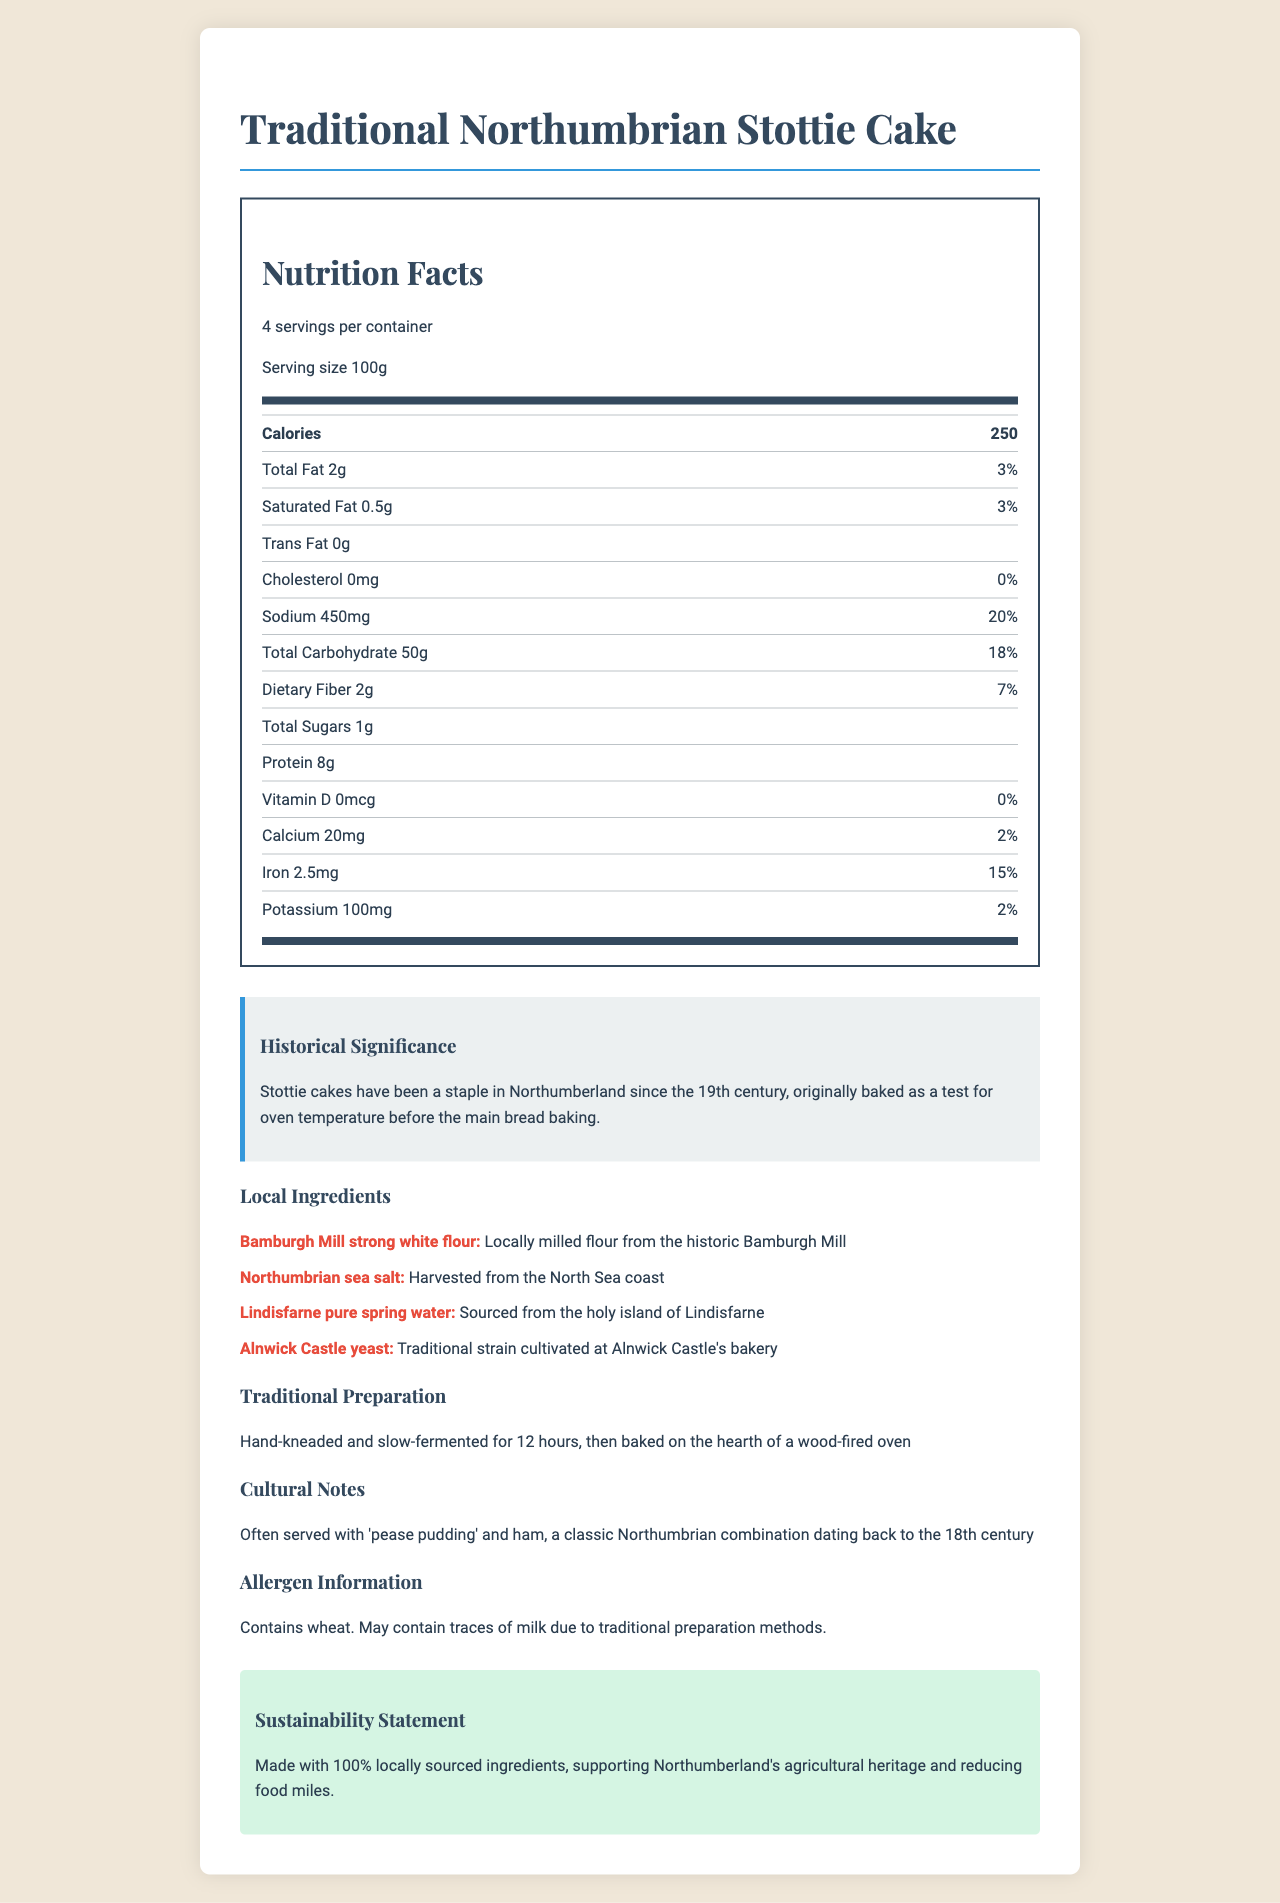what is the serving size for the Traditional Northumbrian Stottie Cake? The document states that the serving size for the Traditional Northumbrian Stottie Cake is 100g.
Answer: 100g how many calories are there per serving? The document specifies that there are 250 calories per serving.
Answer: 250 calories what is the daily value percentage for sodium? The document indicates that the daily value percentage for sodium is 20%.
Answer: 20% how much protein does the Traditional Northumbrian Stottie Cake contain per serving? According to the document, each serving contains 8g of protein.
Answer: 8g what are the main local ingredients used in the Traditional Northumbrian Stottie Cake? The document lists these ingredients as locally sourced: Bamburgh Mill strong white flour, Northumbrian sea salt, Lindisfarne pure spring water, and Alnwick Castle yeast.
Answer: Bamburgh Mill strong white flour, Northumbrian sea salt, Lindisfarne pure spring water, Alnwick Castle yeast how long is the Traditional Northumbrian Stottie Cake slow-fermented for during preparation? The document notes that the cake is slow-fermented for 12 hours during preparation.
Answer: 12 hours where is the Lindisfarne pure spring water sourced from? The document mentions that the Lindisfarne pure spring water is sourced from the holy island of Lindisfarne.
Answer: The holy island of Lindisfarne when did Stottie cakes become a staple in Northumberland? The document states that Stottie cakes have been a staple in Northumberland since the 19th century.
Answer: 19th century which local ingredient is harvested from the North Sea coast? According to the document, Northumbrian sea salt is harvested from the North Sea coast.
Answer: Northumbrian sea salt which cultural combination is the Traditional Northumbrian Stottie Cake often served with? A. Cheese and Tomato B. Pease Pudding and Ham C. Butter and Jam The document indicates that Stottie cake is often served with pease pudding and ham.
Answer: B. Pease Pudding and Ham how much dietary fiber does each serving of the Traditional Northumbrian Stottie Cake contain? A. 1g B. 2g C. 3g D. 4g The document specifies that each serving contains 2g of dietary fiber.
Answer: B. 2g does the Traditional Northumbrian Stottie Cake contain any cholesterol? The document indicates that there is 0mg of cholesterol in the product.
Answer: No summarize the main idea of the document. The document comprehensively discusses the nutritional values, historical significance, and cultural context of the Traditional Northumbrian Stottie Cake, emphasizing its local ingredients and sustainability efforts.
Answer: The document provides detailed nutrition facts and historical and cultural insights about the Traditional Northumbrian Stottie Cake. It highlights its use of local ingredients, traditional preparation methods, and its significance in Northumbrian cuisine. Additionally, it includes allergen information and a sustainability statement supporting local agriculture. what is the address of Bamburgh Mill where the flour is milled? The document does not provide the address of Bamburgh Mill.
Answer: Not enough information is the Traditional Northumbrian Stottie Cake made with any ingredients that support sustainability? The document mentions that the cake is made with 100% locally sourced ingredients, supporting Northumberland's agricultural heritage and reducing food miles.
Answer: Yes 